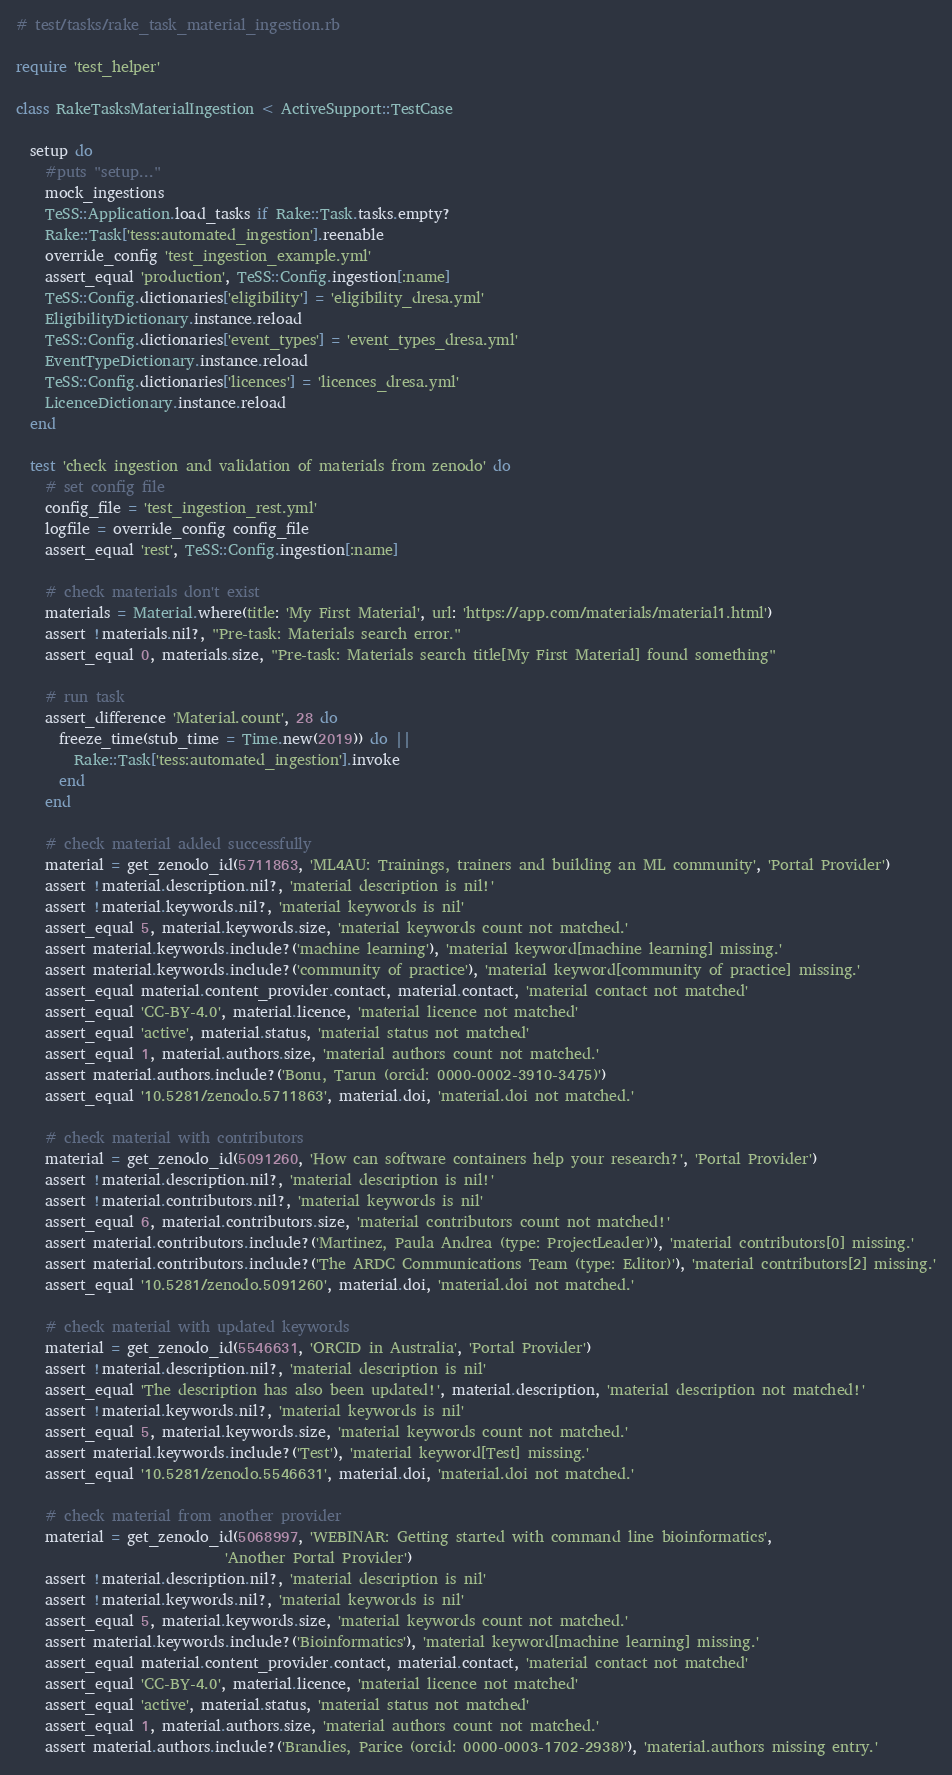Convert code to text. <code><loc_0><loc_0><loc_500><loc_500><_Ruby_># test/tasks/rake_task_material_ingestion.rb

require 'test_helper'

class RakeTasksMaterialIngestion < ActiveSupport::TestCase

  setup do
    #puts "setup..."
    mock_ingestions
    TeSS::Application.load_tasks if Rake::Task.tasks.empty?
    Rake::Task['tess:automated_ingestion'].reenable
    override_config 'test_ingestion_example.yml'
    assert_equal 'production', TeSS::Config.ingestion[:name]
    TeSS::Config.dictionaries['eligibility'] = 'eligibility_dresa.yml'
    EligibilityDictionary.instance.reload
    TeSS::Config.dictionaries['event_types'] = 'event_types_dresa.yml'
    EventTypeDictionary.instance.reload
    TeSS::Config.dictionaries['licences'] = 'licences_dresa.yml'
    LicenceDictionary.instance.reload
  end

  test 'check ingestion and validation of materials from zenodo' do
    # set config file
    config_file = 'test_ingestion_rest.yml'
    logfile = override_config config_file
    assert_equal 'rest', TeSS::Config.ingestion[:name]

    # check materials don't exist
    materials = Material.where(title: 'My First Material', url: 'https://app.com/materials/material1.html')
    assert !materials.nil?, "Pre-task: Materials search error."
    assert_equal 0, materials.size, "Pre-task: Materials search title[My First Material] found something"

    # run task
    assert_difference 'Material.count', 28 do
      freeze_time(stub_time = Time.new(2019)) do ||
        Rake::Task['tess:automated_ingestion'].invoke
      end
    end

    # check material added successfully
    material = get_zenodo_id(5711863, 'ML4AU: Trainings, trainers and building an ML community', 'Portal Provider')
    assert !material.description.nil?, 'material description is nil!'
    assert !material.keywords.nil?, 'material keywords is nil'
    assert_equal 5, material.keywords.size, 'material keywords count not matched.'
    assert material.keywords.include?('machine learning'), 'material keyword[machine learning] missing.'
    assert material.keywords.include?('community of practice'), 'material keyword[community of practice] missing.'
    assert_equal material.content_provider.contact, material.contact, 'material contact not matched'
    assert_equal 'CC-BY-4.0', material.licence, 'material licence not matched'
    assert_equal 'active', material.status, 'material status not matched'
    assert_equal 1, material.authors.size, 'material authors count not matched.'
    assert material.authors.include?('Bonu, Tarun (orcid: 0000-0002-3910-3475)')
    assert_equal '10.5281/zenodo.5711863', material.doi, 'material.doi not matched.'

    # check material with contributors
    material = get_zenodo_id(5091260, 'How can software containers help your research?', 'Portal Provider')
    assert !material.description.nil?, 'material description is nil!'
    assert !material.contributors.nil?, 'material keywords is nil'
    assert_equal 6, material.contributors.size, 'material contributors count not matched!'
    assert material.contributors.include?('Martinez, Paula Andrea (type: ProjectLeader)'), 'material contributors[0] missing.'
    assert material.contributors.include?('The ARDC Communications Team (type: Editor)'), 'material contributors[2] missing.'
    assert_equal '10.5281/zenodo.5091260', material.doi, 'material.doi not matched.'

    # check material with updated keywords
    material = get_zenodo_id(5546631, 'ORCID in Australia', 'Portal Provider')
    assert !material.description.nil?, 'material description is nil'
    assert_equal 'The description has also been updated!', material.description, 'material description not matched!'
    assert !material.keywords.nil?, 'material keywords is nil'
    assert_equal 5, material.keywords.size, 'material keywords count not matched.'
    assert material.keywords.include?('Test'), 'material keyword[Test] missing.'
    assert_equal '10.5281/zenodo.5546631', material.doi, 'material.doi not matched.'

    # check material from another provider
    material = get_zenodo_id(5068997, 'WEBINAR: Getting started with command line bioinformatics',
                             'Another Portal Provider')
    assert !material.description.nil?, 'material description is nil'
    assert !material.keywords.nil?, 'material keywords is nil'
    assert_equal 5, material.keywords.size, 'material keywords count not matched.'
    assert material.keywords.include?('Bioinformatics'), 'material keyword[machine learning] missing.'
    assert_equal material.content_provider.contact, material.contact, 'material contact not matched'
    assert_equal 'CC-BY-4.0', material.licence, 'material licence not matched'
    assert_equal 'active', material.status, 'material status not matched'
    assert_equal 1, material.authors.size, 'material authors count not matched.'
    assert material.authors.include?('Brandies, Parice (orcid: 0000-0003-1702-2938)'), 'material.authors missing entry.'</code> 